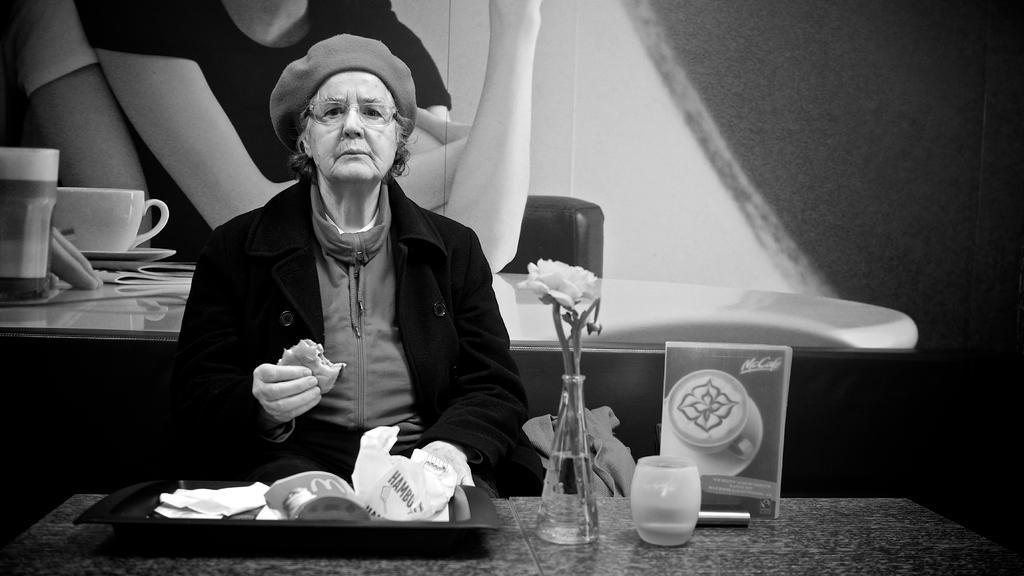Describe this image in one or two sentences. in the picture we can see an old woman eating,we can also see a tray on the table and a flower vase. 